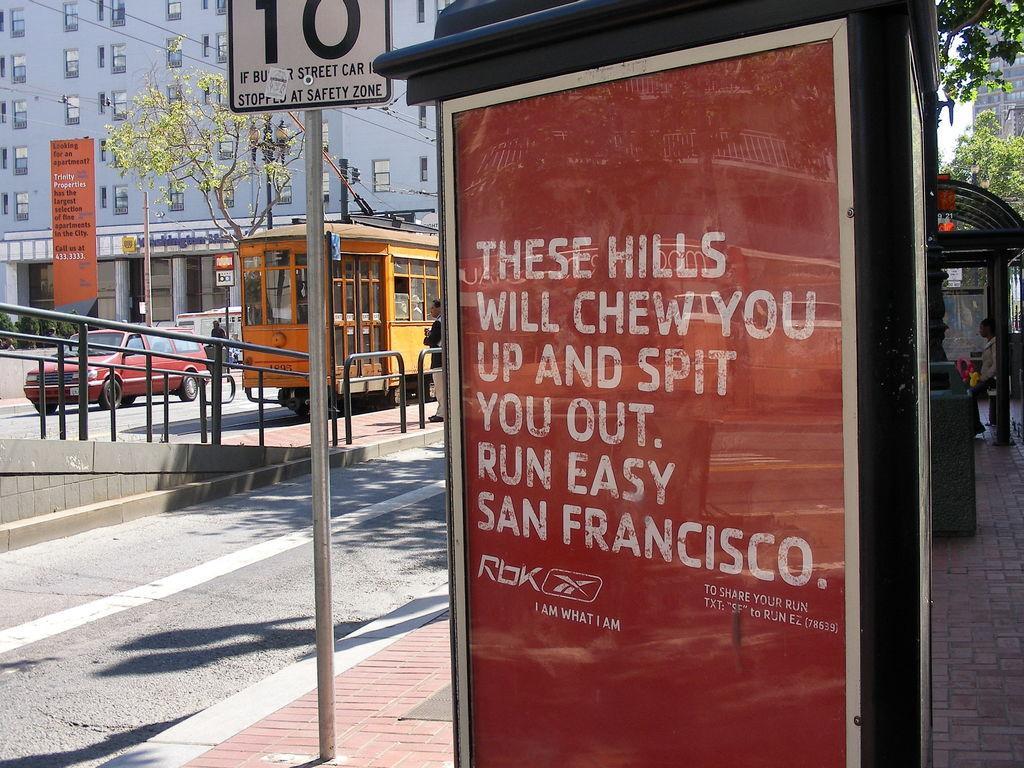Please provide a concise description of this image. This picture is clicked outside. In the foreground we can see the text on the boards. In the right corner there is a person sitting on the bench and we can see the metal rods. In the center we can see the vehicles running on the road and we can see the two people seems to be standing on the ground and we can see the metal rods, text on the banner, tree, lamp post. In the background we can see the building and the plants. In the right corner we can see the sky, building and the trees and we can see some other objects. 